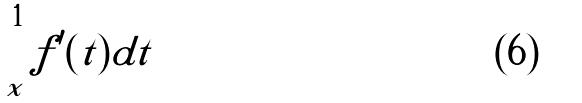<formula> <loc_0><loc_0><loc_500><loc_500>\int _ { x } ^ { 1 } f ^ { \prime } ( t ) d t</formula> 